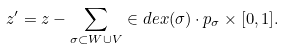Convert formula to latex. <formula><loc_0><loc_0><loc_500><loc_500>z ^ { \prime } = z - \sum _ { \sigma \subset W \cup V } \in d e x ( \sigma ) \cdot p _ { \sigma } \times [ 0 , 1 ] .</formula> 